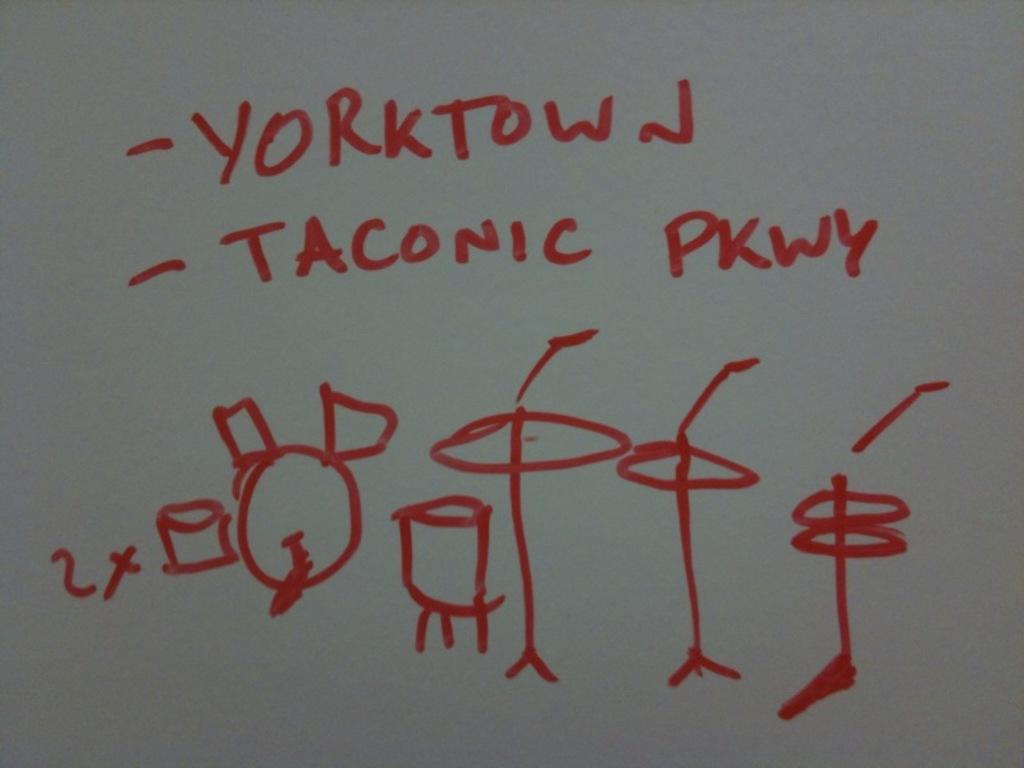<image>
Summarize the visual content of the image. Drums and cymbals are drawn on a whiteboard with Yorktown Taconic Pkwy written above. 